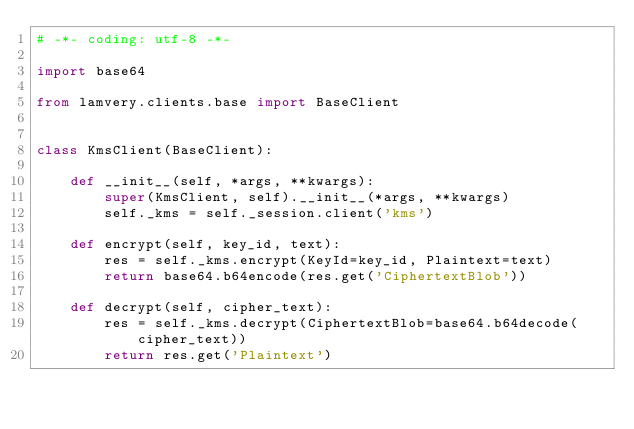<code> <loc_0><loc_0><loc_500><loc_500><_Python_># -*- coding: utf-8 -*-

import base64

from lamvery.clients.base import BaseClient


class KmsClient(BaseClient):

    def __init__(self, *args, **kwargs):
        super(KmsClient, self).__init__(*args, **kwargs)
        self._kms = self._session.client('kms')

    def encrypt(self, key_id, text):
        res = self._kms.encrypt(KeyId=key_id, Plaintext=text)
        return base64.b64encode(res.get('CiphertextBlob'))

    def decrypt(self, cipher_text):
        res = self._kms.decrypt(CiphertextBlob=base64.b64decode(cipher_text))
        return res.get('Plaintext')
</code> 